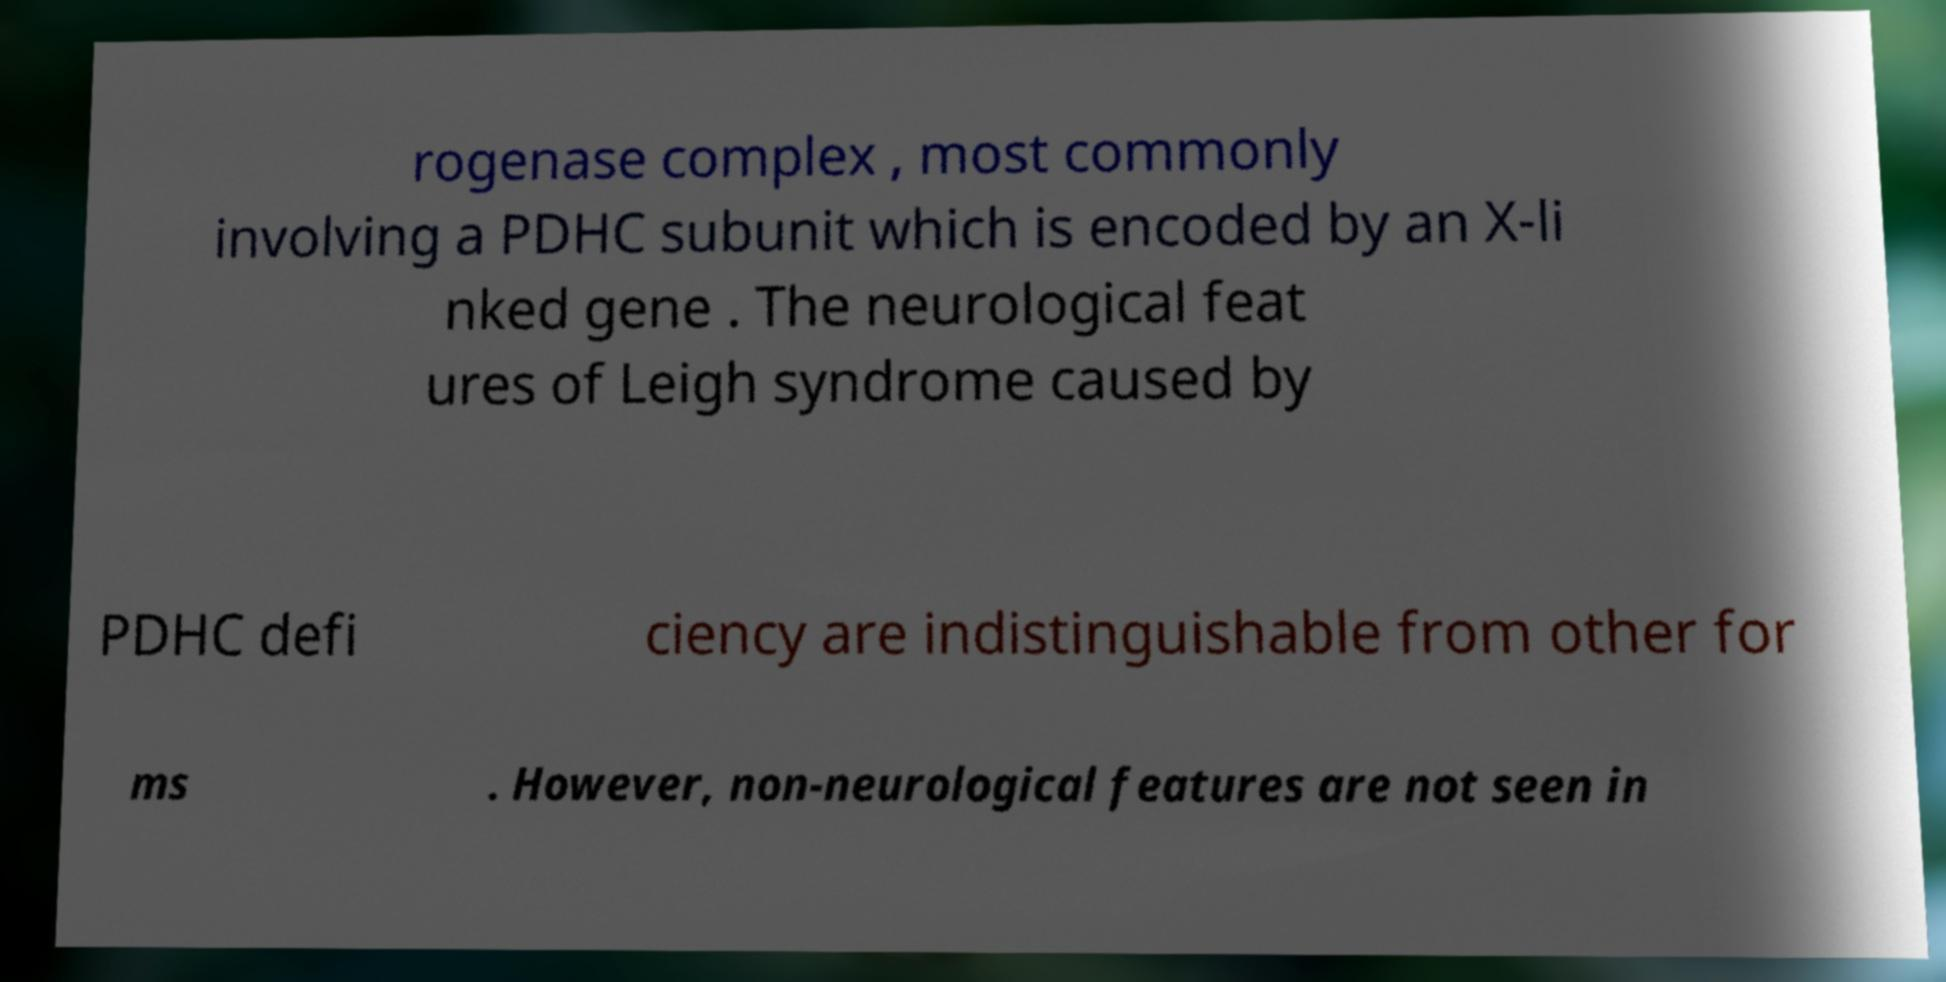Can you read and provide the text displayed in the image?This photo seems to have some interesting text. Can you extract and type it out for me? rogenase complex , most commonly involving a PDHC subunit which is encoded by an X-li nked gene . The neurological feat ures of Leigh syndrome caused by PDHC defi ciency are indistinguishable from other for ms . However, non-neurological features are not seen in 